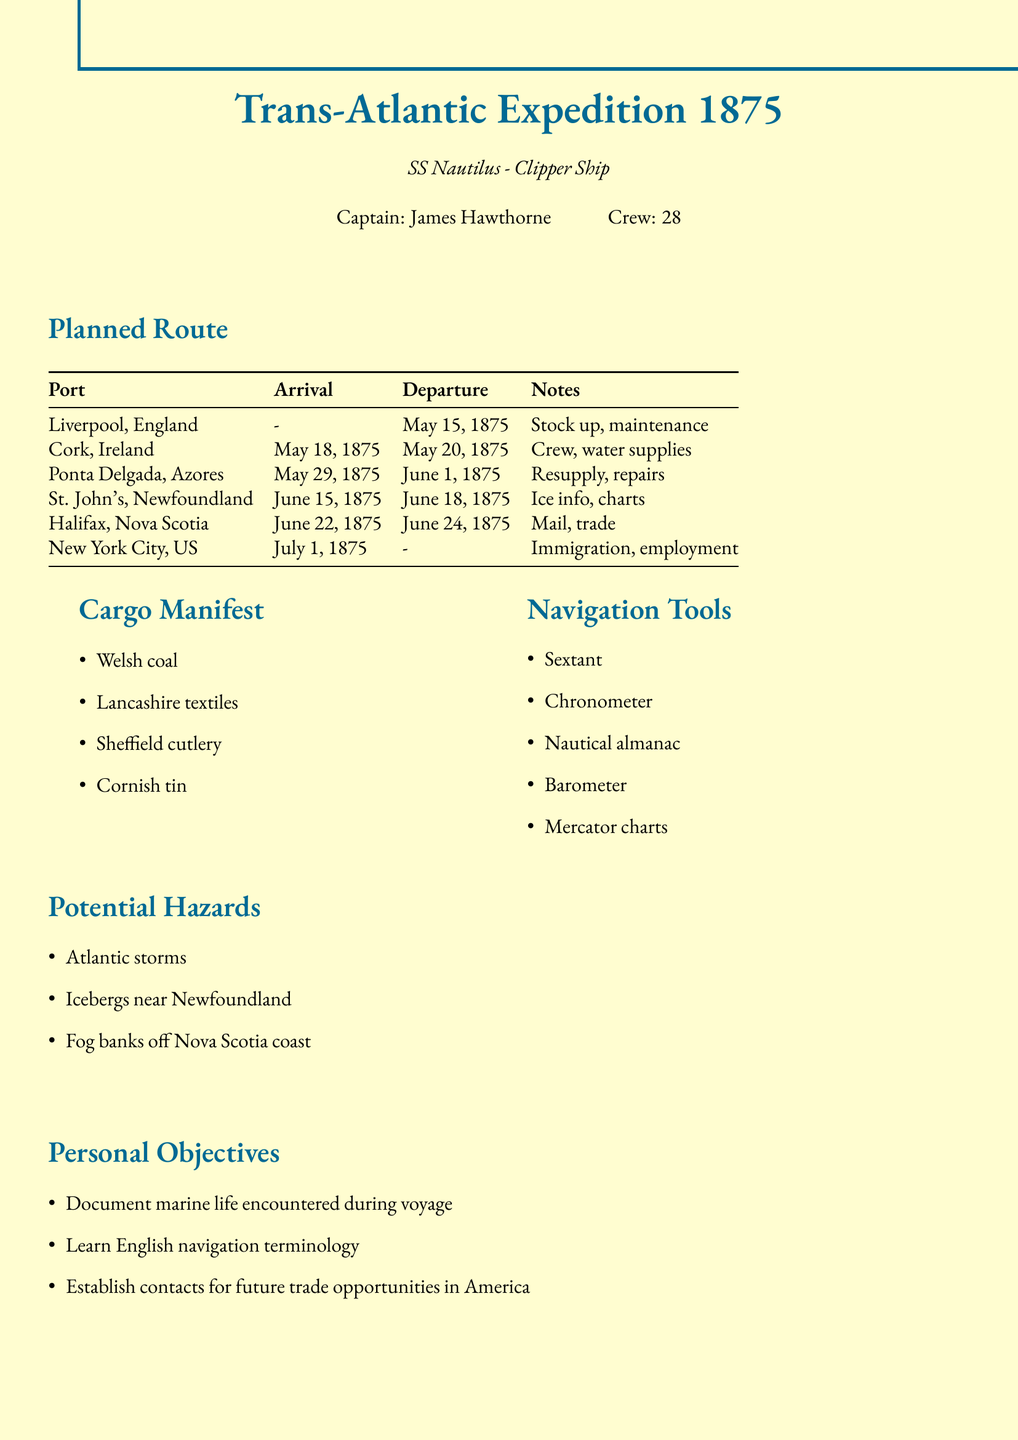What is the name of the ship? The ship's name is explicitly stated in the document, which is "SS Nautilus".
Answer: SS Nautilus Who is the captain of the SS Nautilus? The document mentions the captain's name directly, which is "James Hawthorne".
Answer: James Hawthorne What is the estimated arrival date at New York City? The document specifies the estimated arrival date for New York City as "July 1, 1875".
Answer: July 1, 1875 How many crew members are on board? The crew size is clearly indicated in the document as "28".
Answer: 28 What is the first port of call? The first port listed in the planned route is "Liverpool, England".
Answer: Liverpool, England What major concern is noted for Newfoundland? The document lists “ice conditions” as a key information point to gather at Newfoundland.
Answer: Ice conditions How long is the stay planned at Halifax? The document states that the estimated stay at Halifax is from June 22, 1875 to June 24, 1875, which totals two days.
Answer: Two days What are the potential hazards mentioned for this voyage? The document lists three potential hazards: "Atlantic storms", "icebergs near Newfoundland", and "fog banks off Nova Scotia coast".
Answer: Atlantic storms, icebergs, fog banks What is one of the personal objectives of the captain? The document mentions the goal of "documenting marine life encountered during voyage" as one of the personal objectives.
Answer: Document marine life 